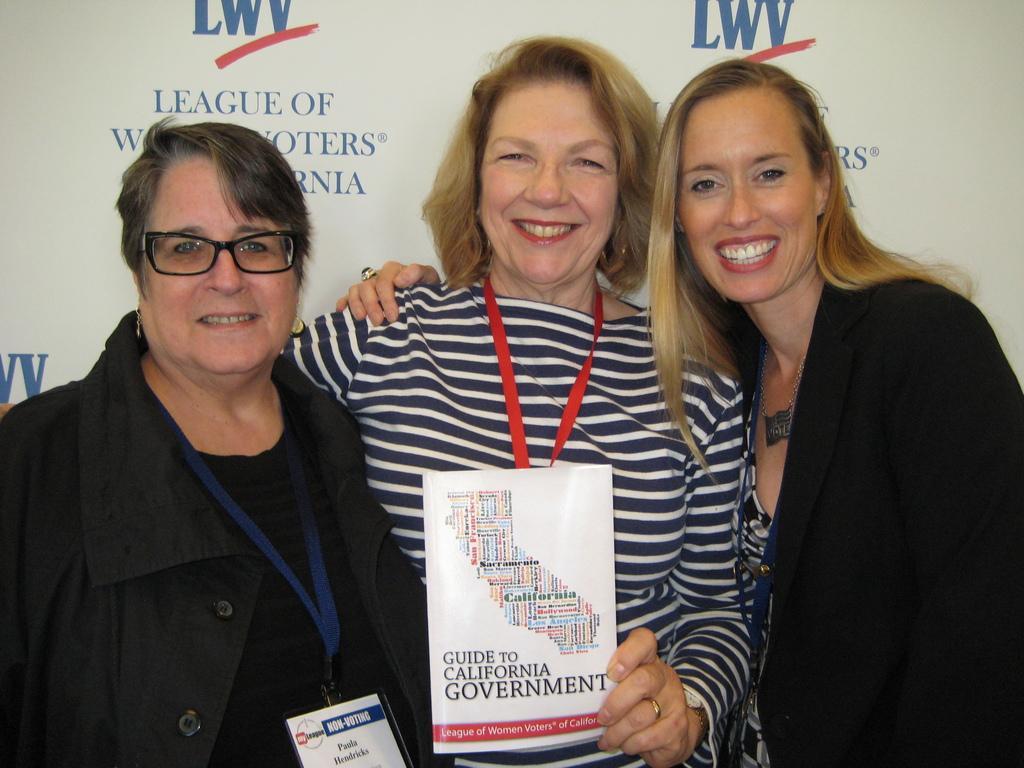Please provide a concise description of this image. There is a lady standing in the center of the image holding a pamphlet in her hand, there are other ladies on both the sides and a poster in the background area. 